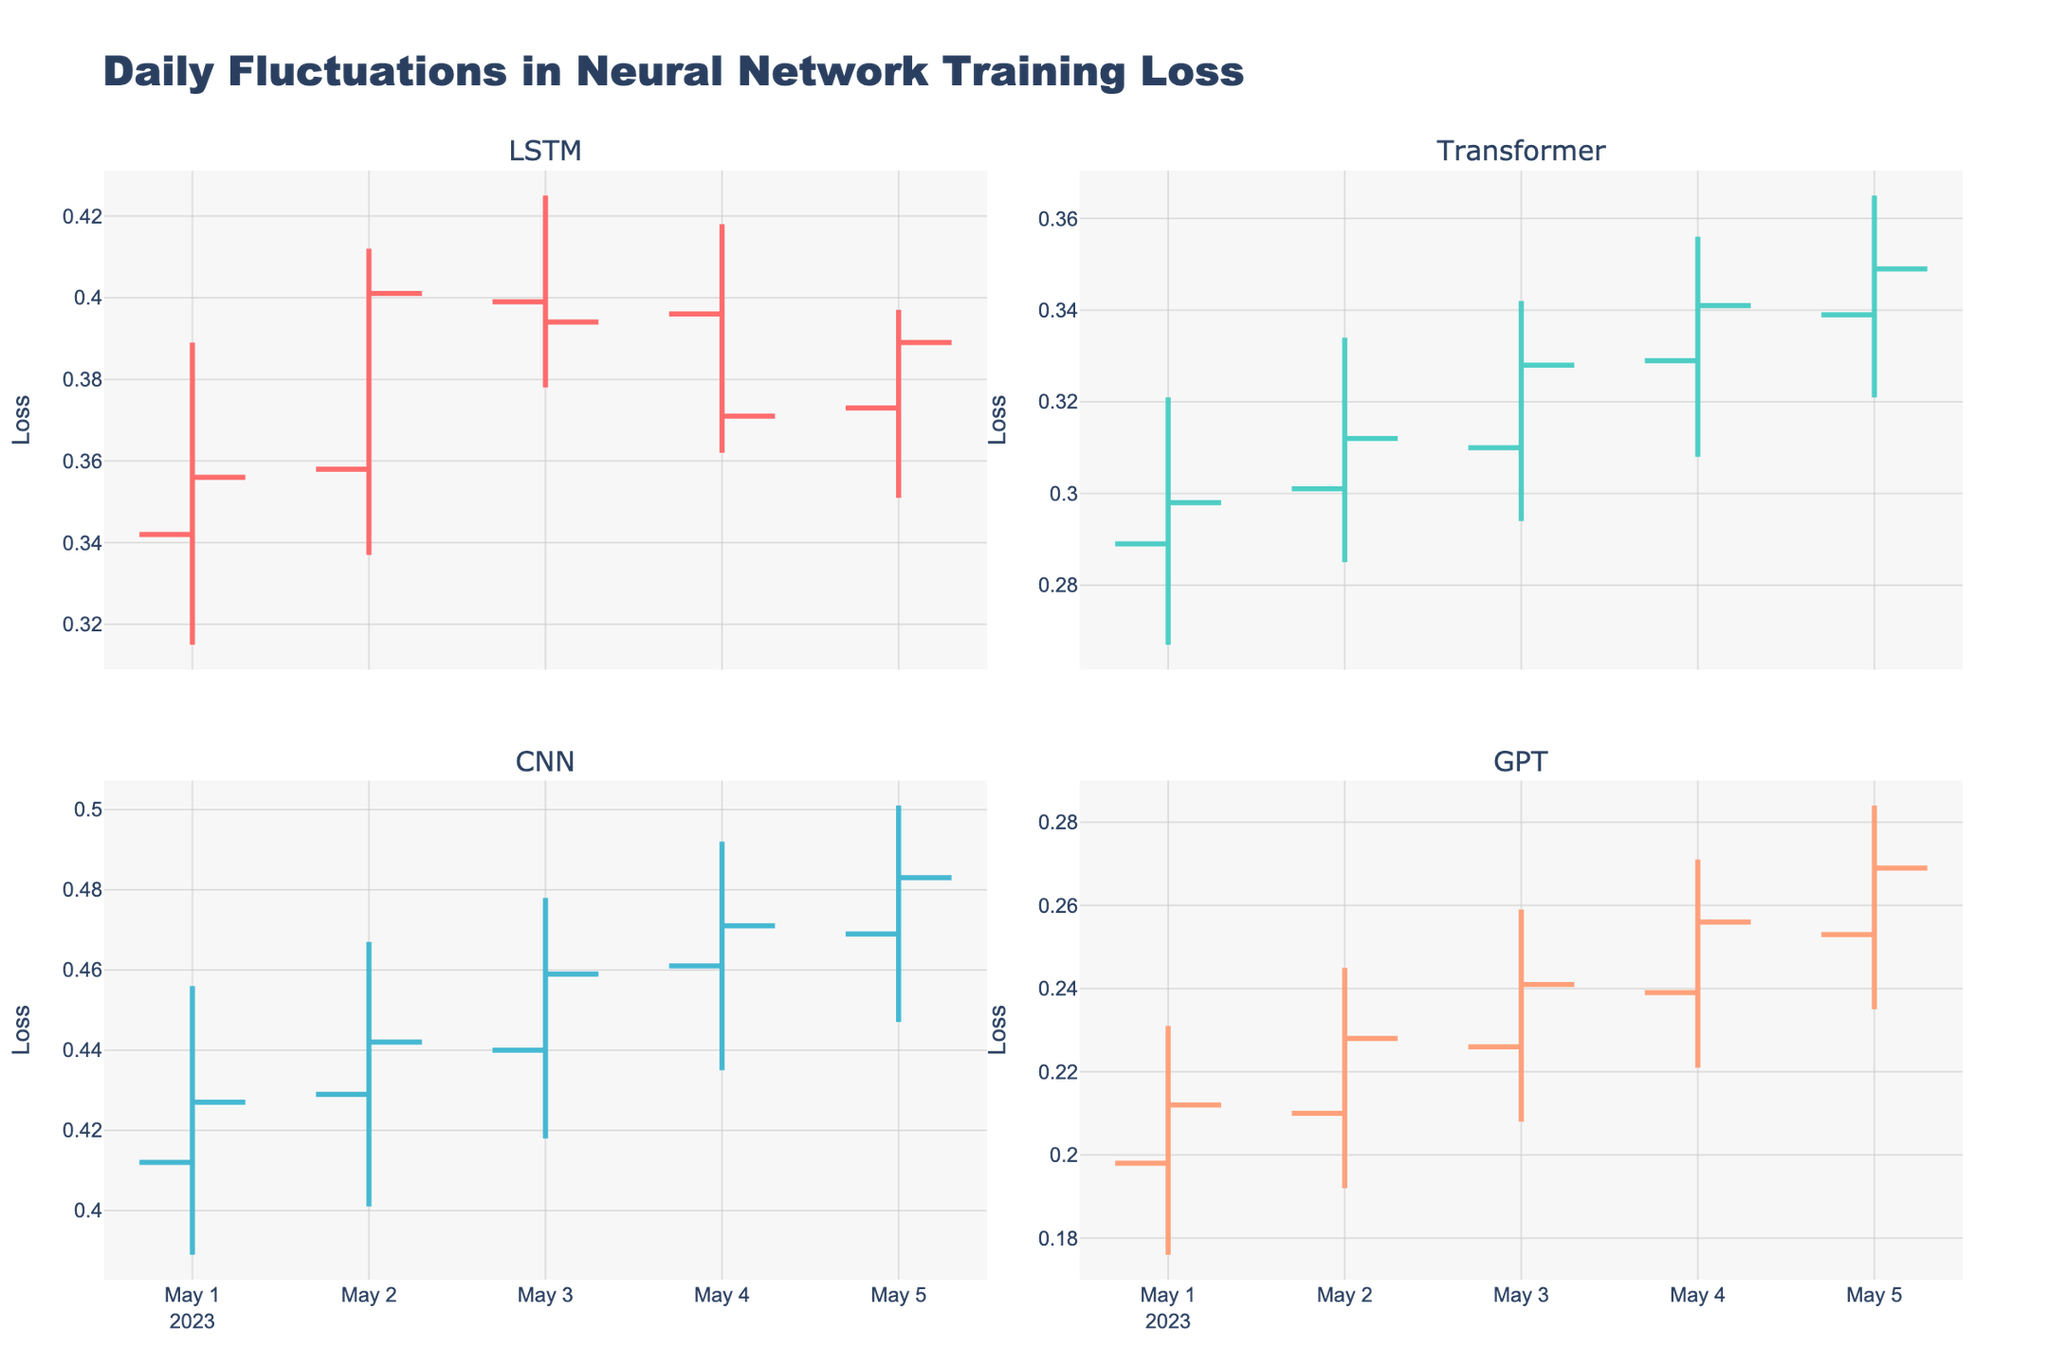What's the title of the plot? The title is displayed prominently at the top of the figure. It reads "Daily Fluctuations in Neural Network Training Loss".
Answer: Daily Fluctuations in Neural Network Training Loss Which architecture shows the highest closing loss value on May 2? By observing the closing values on May 2 for all architectures, we find that CNN has the highest closing value at 0.442.
Answer: CNN Which architecture has the smallest range (difference between high and low) on May 3? Calculate the range for each architecture on May 3. LSTM range is 0.425-0.378=0.047. Transformer range is 0.342-0.294=0.048. CNN range is 0.478-0.418=0.06. GPT range is 0.259-0.208=0.051. LSTM has the smallest range of 0.047.
Answer: LSTM Which architecture's loss increased the most from May 1 to May 5? Compute the change in closing loss from May 1 to May 5 for each architecture: LSTM (0.389 - 0.356 = 0.033), Transformer (0.349 - 0.298 = 0.051), CNN (0.483 - 0.427 = 0.056), GPT (0.269 - 0.212 = 0.057). The loss of GPT increased the most by 0.057.
Answer: GPT What is the average closing loss on May 4 across all architectures? Sum of closing losses on May 4 (LSTM: 0.371, Transformer: 0.341, CNN: 0.471, GPT: 0.256) divided by 4. Calculation: (0.371 + 0.341 + 0.471 + 0.256) / 4 = 0.35975.
Answer: 0.35975 Which architecture showed the most volatile behavior (highest high to lowest low) on any single day, and on which day? Checking all days, for each architecture: LSTM: 2023-05-02 (0.412 - 0.337 = 0.075), Transformer: 2023-05-05 (0.365 - 0.321 = 0.044), CNN: 2023-05-05 (0.501 - 0.447 = 0.054), GPT: 2023-05-05 (0.284 - 0.235 = 0.049). LSTM on May 2 shows the most volatility with 0.075.
Answer: LSTM on May 2 What is the trend direction (increasing or decreasing) for the closing value of the Transformer architecture from May 1 to May 5? Tracking the closing values for Transformer from May 1 to May 5: 0.298, 0.312, 0.328, 0.341, 0.349. The values are consistently increasing.
Answer: Increasing 